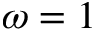<formula> <loc_0><loc_0><loc_500><loc_500>\omega = 1</formula> 